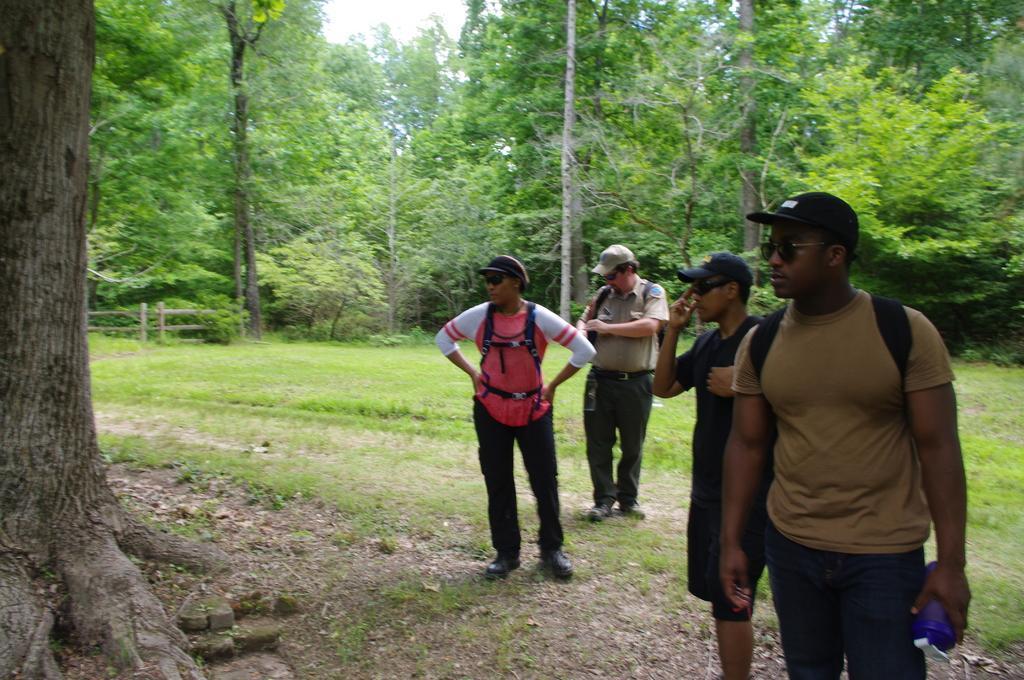In one or two sentences, can you explain what this image depicts? In this image we can see people standing on the ground. In the background there are trees, wooden fence and sky. 